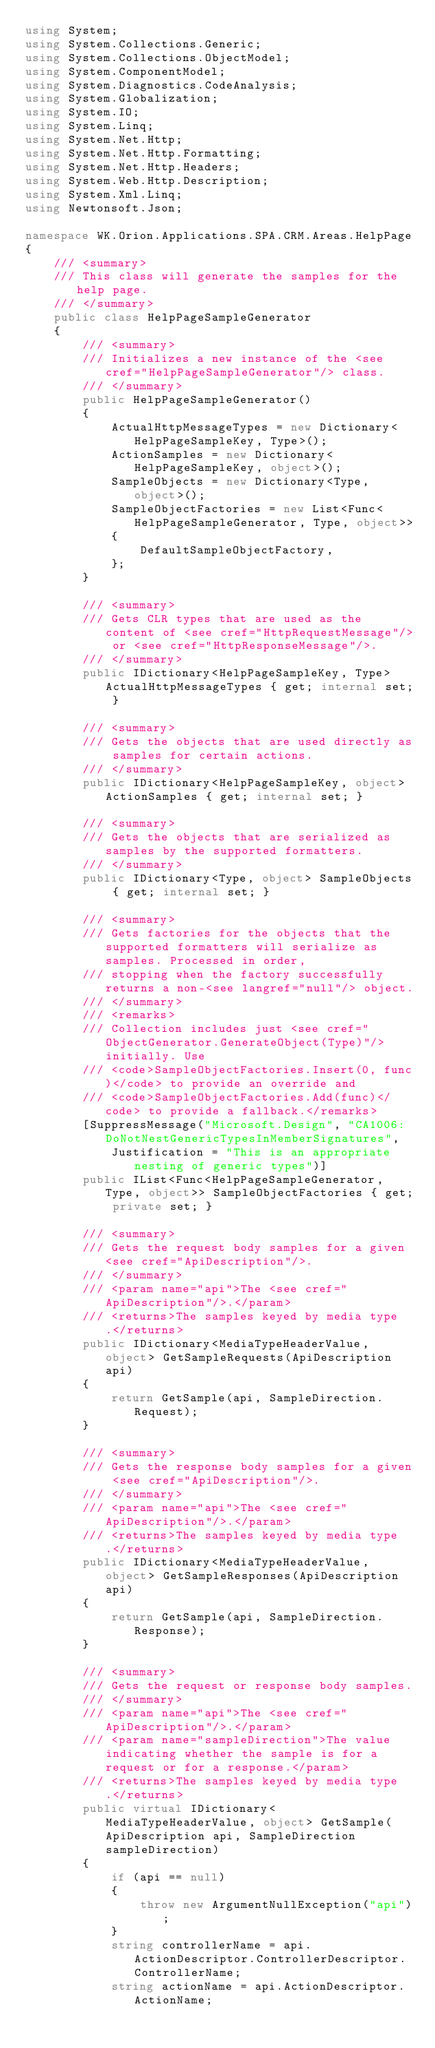Convert code to text. <code><loc_0><loc_0><loc_500><loc_500><_C#_>using System;
using System.Collections.Generic;
using System.Collections.ObjectModel;
using System.ComponentModel;
using System.Diagnostics.CodeAnalysis;
using System.Globalization;
using System.IO;
using System.Linq;
using System.Net.Http;
using System.Net.Http.Formatting;
using System.Net.Http.Headers;
using System.Web.Http.Description;
using System.Xml.Linq;
using Newtonsoft.Json;

namespace WK.Orion.Applications.SPA.CRM.Areas.HelpPage
{
    /// <summary>
    /// This class will generate the samples for the help page.
    /// </summary>
    public class HelpPageSampleGenerator
    {
        /// <summary>
        /// Initializes a new instance of the <see cref="HelpPageSampleGenerator"/> class.
        /// </summary>
        public HelpPageSampleGenerator()
        {
            ActualHttpMessageTypes = new Dictionary<HelpPageSampleKey, Type>();
            ActionSamples = new Dictionary<HelpPageSampleKey, object>();
            SampleObjects = new Dictionary<Type, object>();
            SampleObjectFactories = new List<Func<HelpPageSampleGenerator, Type, object>>
            {
                DefaultSampleObjectFactory,
            };
        }

        /// <summary>
        /// Gets CLR types that are used as the content of <see cref="HttpRequestMessage"/> or <see cref="HttpResponseMessage"/>.
        /// </summary>
        public IDictionary<HelpPageSampleKey, Type> ActualHttpMessageTypes { get; internal set; }

        /// <summary>
        /// Gets the objects that are used directly as samples for certain actions.
        /// </summary>
        public IDictionary<HelpPageSampleKey, object> ActionSamples { get; internal set; }

        /// <summary>
        /// Gets the objects that are serialized as samples by the supported formatters.
        /// </summary>
        public IDictionary<Type, object> SampleObjects { get; internal set; }

        /// <summary>
        /// Gets factories for the objects that the supported formatters will serialize as samples. Processed in order,
        /// stopping when the factory successfully returns a non-<see langref="null"/> object.
        /// </summary>
        /// <remarks>
        /// Collection includes just <see cref="ObjectGenerator.GenerateObject(Type)"/> initially. Use
        /// <code>SampleObjectFactories.Insert(0, func)</code> to provide an override and
        /// <code>SampleObjectFactories.Add(func)</code> to provide a fallback.</remarks>
        [SuppressMessage("Microsoft.Design", "CA1006:DoNotNestGenericTypesInMemberSignatures",
            Justification = "This is an appropriate nesting of generic types")]
        public IList<Func<HelpPageSampleGenerator, Type, object>> SampleObjectFactories { get; private set; }

        /// <summary>
        /// Gets the request body samples for a given <see cref="ApiDescription"/>.
        /// </summary>
        /// <param name="api">The <see cref="ApiDescription"/>.</param>
        /// <returns>The samples keyed by media type.</returns>
        public IDictionary<MediaTypeHeaderValue, object> GetSampleRequests(ApiDescription api)
        {
            return GetSample(api, SampleDirection.Request);
        }

        /// <summary>
        /// Gets the response body samples for a given <see cref="ApiDescription"/>.
        /// </summary>
        /// <param name="api">The <see cref="ApiDescription"/>.</param>
        /// <returns>The samples keyed by media type.</returns>
        public IDictionary<MediaTypeHeaderValue, object> GetSampleResponses(ApiDescription api)
        {
            return GetSample(api, SampleDirection.Response);
        }

        /// <summary>
        /// Gets the request or response body samples.
        /// </summary>
        /// <param name="api">The <see cref="ApiDescription"/>.</param>
        /// <param name="sampleDirection">The value indicating whether the sample is for a request or for a response.</param>
        /// <returns>The samples keyed by media type.</returns>
        public virtual IDictionary<MediaTypeHeaderValue, object> GetSample(ApiDescription api, SampleDirection sampleDirection)
        {
            if (api == null)
            {
                throw new ArgumentNullException("api");
            }
            string controllerName = api.ActionDescriptor.ControllerDescriptor.ControllerName;
            string actionName = api.ActionDescriptor.ActionName;</code> 